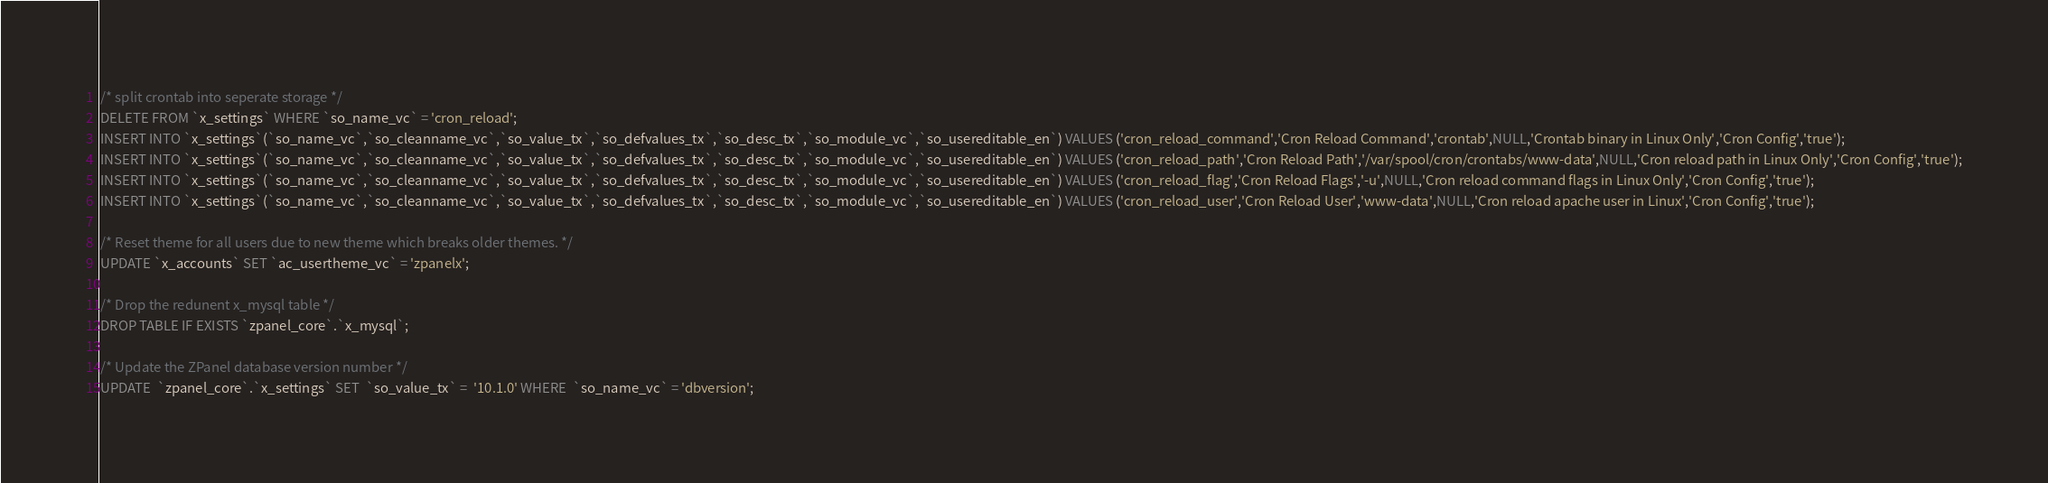<code> <loc_0><loc_0><loc_500><loc_500><_SQL_>
/* split crontab into seperate storage */
DELETE FROM `x_settings` WHERE `so_name_vc` = 'cron_reload';
INSERT INTO `x_settings`(`so_name_vc`,`so_cleanname_vc`,`so_value_tx`,`so_defvalues_tx`,`so_desc_tx`,`so_module_vc`,`so_usereditable_en`) VALUES ('cron_reload_command','Cron Reload Command','crontab',NULL,'Crontab binary in Linux Only','Cron Config','true');
INSERT INTO `x_settings`(`so_name_vc`,`so_cleanname_vc`,`so_value_tx`,`so_defvalues_tx`,`so_desc_tx`,`so_module_vc`,`so_usereditable_en`) VALUES ('cron_reload_path','Cron Reload Path','/var/spool/cron/crontabs/www-data',NULL,'Cron reload path in Linux Only','Cron Config','true');
INSERT INTO `x_settings`(`so_name_vc`,`so_cleanname_vc`,`so_value_tx`,`so_defvalues_tx`,`so_desc_tx`,`so_module_vc`,`so_usereditable_en`) VALUES ('cron_reload_flag','Cron Reload Flags','-u',NULL,'Cron reload command flags in Linux Only','Cron Config','true');
INSERT INTO `x_settings`(`so_name_vc`,`so_cleanname_vc`,`so_value_tx`,`so_defvalues_tx`,`so_desc_tx`,`so_module_vc`,`so_usereditable_en`) VALUES ('cron_reload_user','Cron Reload User','www-data',NULL,'Cron reload apache user in Linux','Cron Config','true');

/* Reset theme for all users due to new theme which breaks older themes. */
UPDATE `x_accounts` SET `ac_usertheme_vc` = 'zpanelx';

/* Drop the redunent x_mysql table */
DROP TABLE IF EXISTS `zpanel_core`.`x_mysql`;

/* Update the ZPanel database version number */
UPDATE  `zpanel_core`.`x_settings` SET  `so_value_tx` =  '10.1.0' WHERE  `so_name_vc` = 'dbversion';</code> 